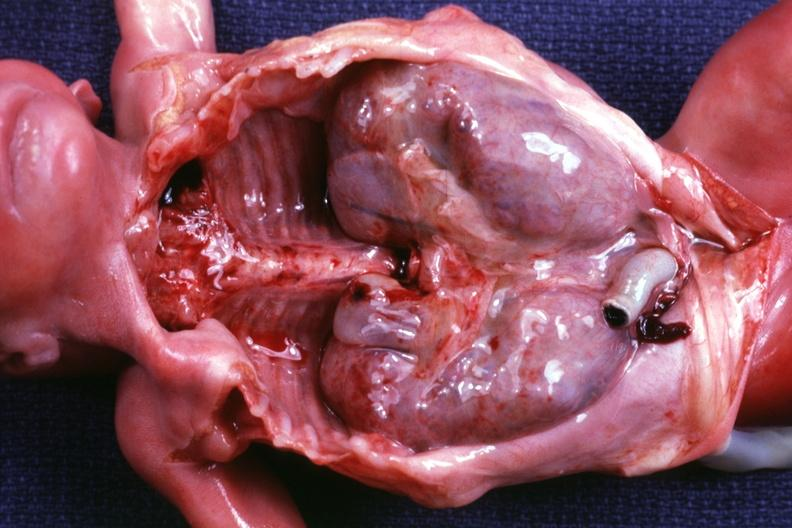what removed dramatic demonstration of size of kidneys?
Answer the question using a single word or phrase. Other organs 